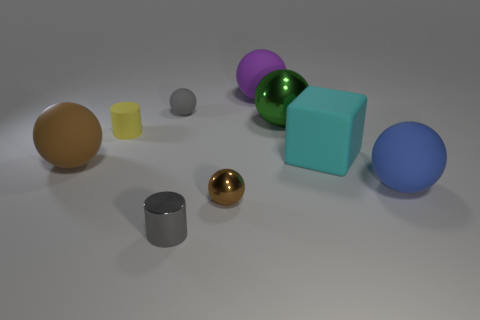Does the tiny matte sphere have the same color as the metallic cylinder?
Give a very brief answer. Yes. What number of big balls are behind the large cube?
Make the answer very short. 2. What number of other objects are there of the same size as the green metallic sphere?
Your response must be concise. 4. Does the brown thing that is left of the tiny yellow cylinder have the same material as the green sphere that is in front of the big purple ball?
Keep it short and to the point. No. What color is the cube that is the same size as the purple rubber sphere?
Make the answer very short. Cyan. Are there any other things that have the same color as the small metallic cylinder?
Your answer should be compact. Yes. What size is the purple rubber object behind the big matte sphere that is right of the big green thing that is on the left side of the big cyan block?
Your response must be concise. Large. The rubber thing that is both on the right side of the small metallic ball and behind the large cyan object is what color?
Provide a short and direct response. Purple. What size is the brown thing to the left of the small gray shiny object?
Offer a very short reply. Large. How many big yellow blocks have the same material as the purple ball?
Keep it short and to the point. 0. 